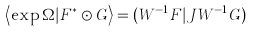Convert formula to latex. <formula><loc_0><loc_0><loc_500><loc_500>\left \langle \exp \Omega | F ^ { * } \odot G \right \rangle = ( W ^ { - 1 } F | J W ^ { - 1 } G )</formula> 